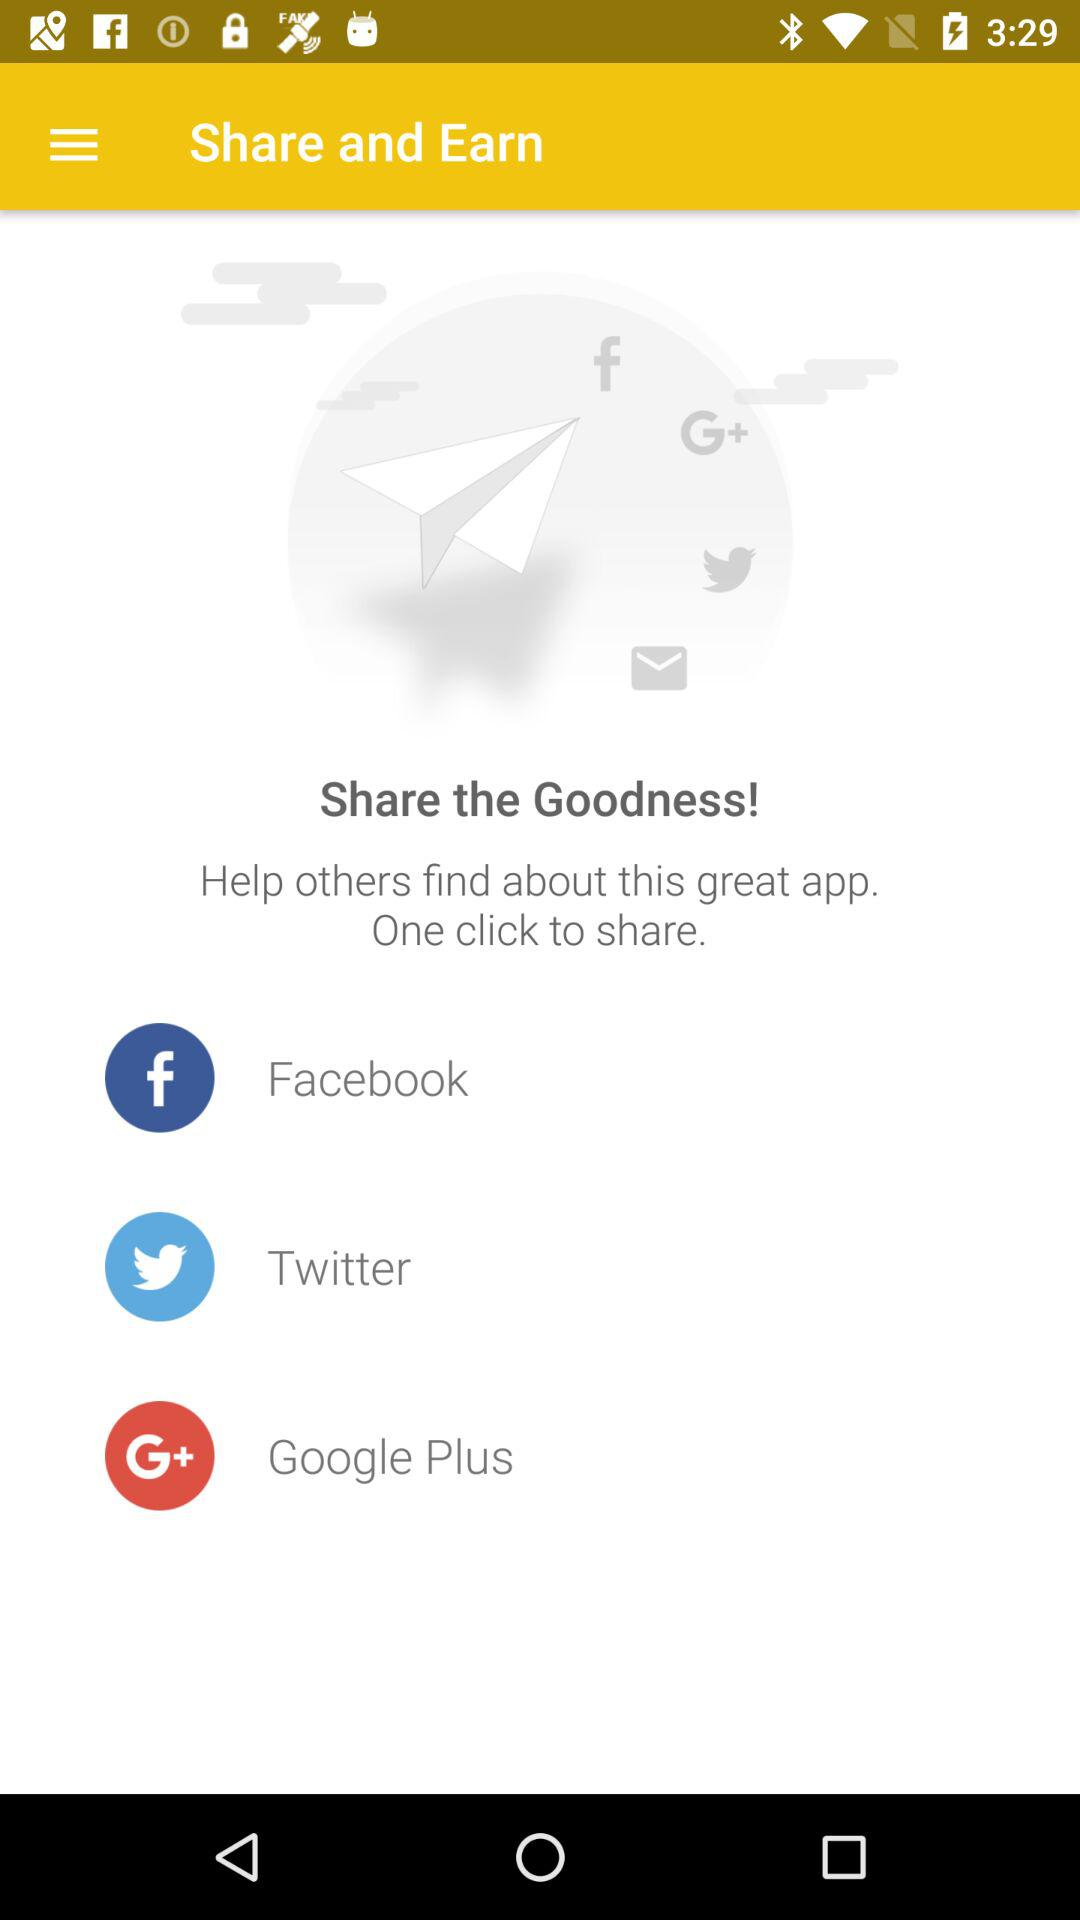What accounts can I use to share? You can share it through "Facebook", "Twitter" and "Google Plus". 